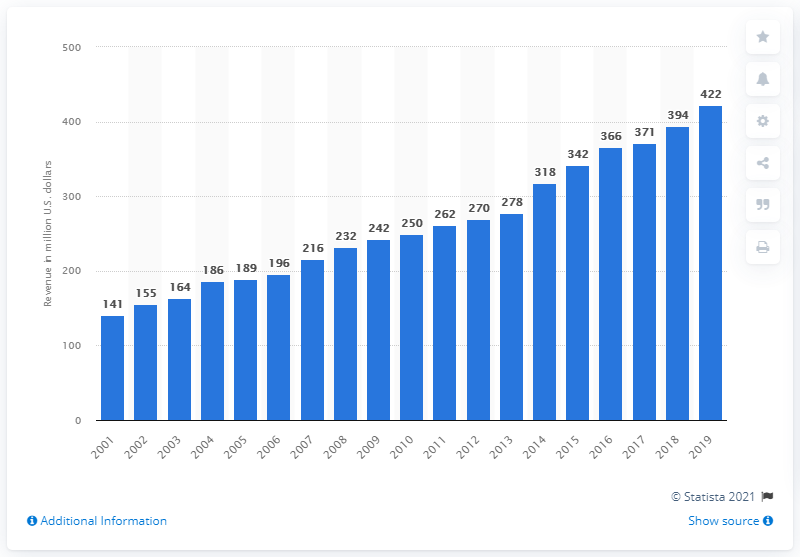Mention a couple of crucial points in this snapshot. The Tennessee Titans were last established as a franchise in 2001. In 2019, the revenue of the Tennessee Titans was approximately 422 million dollars. 